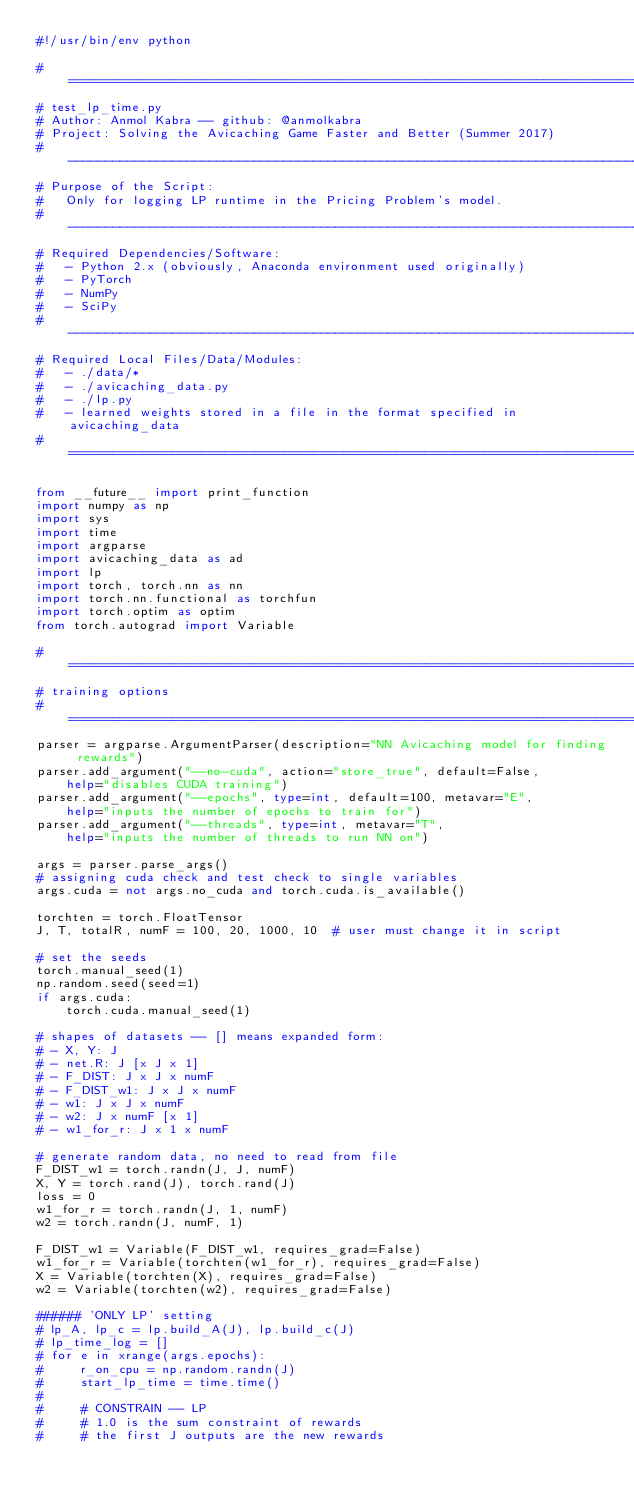Convert code to text. <code><loc_0><loc_0><loc_500><loc_500><_Python_>#!/usr/bin/env python

# =============================================================================
# test_lp_time.py
# Author: Anmol Kabra -- github: @anmolkabra
# Project: Solving the Avicaching Game Faster and Better (Summer 2017)
# -----------------------------------------------------------------------------
# Purpose of the Script:
#   Only for logging LP runtime in the Pricing Problem's model.
# -----------------------------------------------------------------------------
# Required Dependencies/Software:
#   - Python 2.x (obviously, Anaconda environment used originally)
#   - PyTorch
#   - NumPy
#   - SciPy
# -----------------------------------------------------------------------------
# Required Local Files/Data/Modules:
#   - ./data/*
#   - ./avicaching_data.py
#   - ./lp.py
#   - learned weights stored in a file in the format specified in avicaching_data
# =============================================================================

from __future__ import print_function
import numpy as np
import sys
import time
import argparse
import avicaching_data as ad
import lp
import torch, torch.nn as nn
import torch.nn.functional as torchfun
import torch.optim as optim
from torch.autograd import Variable

# =============================================================================
# training options
# =============================================================================
parser = argparse.ArgumentParser(description="NN Avicaching model for finding rewards")
parser.add_argument("--no-cuda", action="store_true", default=False,
    help="disables CUDA training")
parser.add_argument("--epochs", type=int, default=100, metavar="E",
    help="inputs the number of epochs to train for")
parser.add_argument("--threads", type=int, metavar="T",
    help="inputs the number of threads to run NN on")

args = parser.parse_args()
# assigning cuda check and test check to single variables
args.cuda = not args.no_cuda and torch.cuda.is_available()

torchten = torch.FloatTensor
J, T, totalR, numF = 100, 20, 1000, 10  # user must change it in script

# set the seeds
torch.manual_seed(1)
np.random.seed(seed=1)
if args.cuda:
    torch.cuda.manual_seed(1)

# shapes of datasets -- [] means expanded form:
# - X, Y: J
# - net.R: J [x J x 1]
# - F_DIST: J x J x numF
# - F_DIST_w1: J x J x numF
# - w1: J x J x numF
# - w2: J x numF [x 1]
# - w1_for_r: J x 1 x numF

# generate random data, no need to read from file
F_DIST_w1 = torch.randn(J, J, numF)
X, Y = torch.rand(J), torch.rand(J)
loss = 0
w1_for_r = torch.randn(J, 1, numF)
w2 = torch.randn(J, numF, 1)

F_DIST_w1 = Variable(F_DIST_w1, requires_grad=False)
w1_for_r = Variable(torchten(w1_for_r), requires_grad=False)
X = Variable(torchten(X), requires_grad=False)
w2 = Variable(torchten(w2), requires_grad=False)

###### 'ONLY LP' setting
# lp_A, lp_c = lp.build_A(J), lp.build_c(J)
# lp_time_log = []
# for e in xrange(args.epochs):
#     r_on_cpu = np.random.randn(J)
#     start_lp_time = time.time()
#    
#     # CONSTRAIN -- LP
#     # 1.0 is the sum constraint of rewards
#     # the first J outputs are the new rewards</code> 